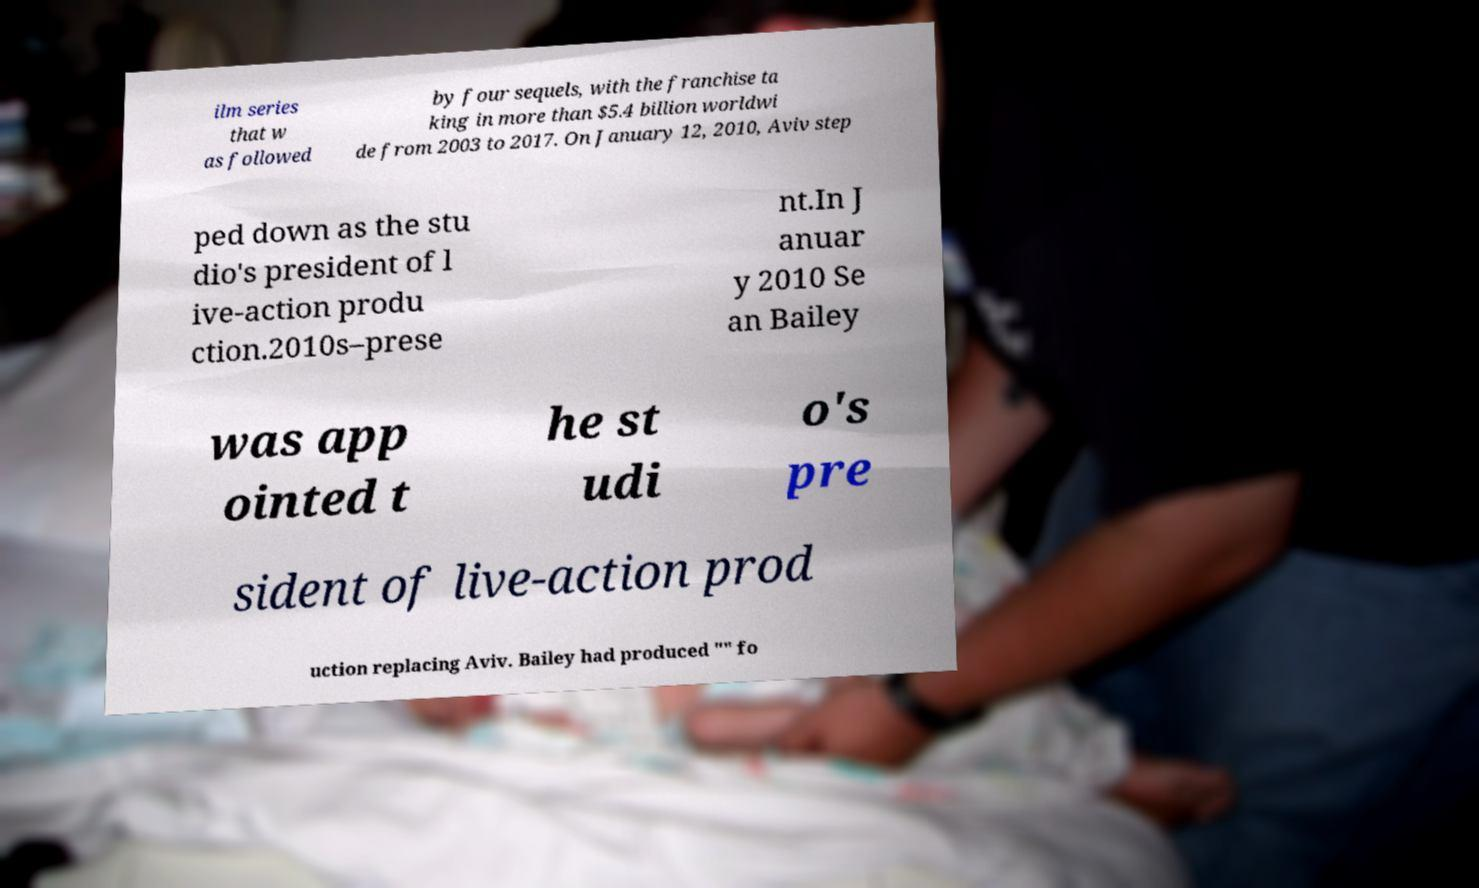Please read and relay the text visible in this image. What does it say? ilm series that w as followed by four sequels, with the franchise ta king in more than $5.4 billion worldwi de from 2003 to 2017. On January 12, 2010, Aviv step ped down as the stu dio's president of l ive-action produ ction.2010s–prese nt.In J anuar y 2010 Se an Bailey was app ointed t he st udi o's pre sident of live-action prod uction replacing Aviv. Bailey had produced "" fo 